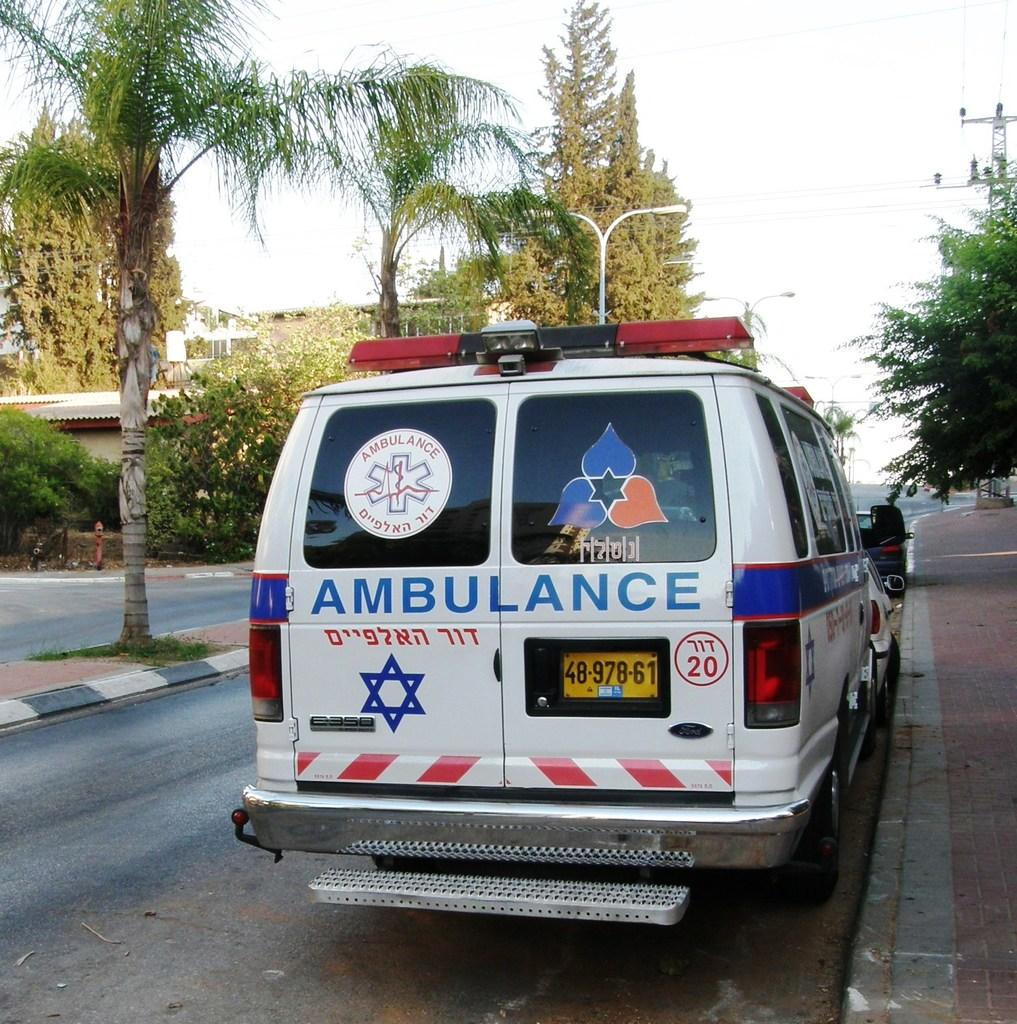<image>
Render a clear and concise summary of the photo. An ambulance with a yellow license plate is parked on the side of a road. 